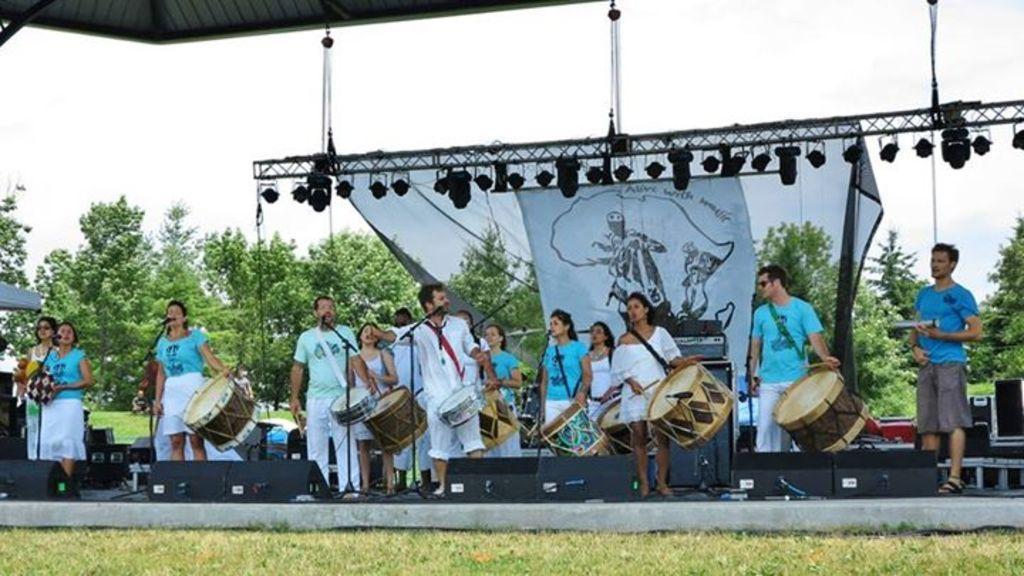Could you give a brief overview of what you see in this image? This picture is clicked outside. In the foreground we can see the green grass. In the center we can see the group of people standing on the ground and seems to be playing musical instruments and there are some microphones attached to the stands. At the top we can see the tent, focusing lights attached to the metal rods. In the background we can see a white color curtain and we can see the sky and the trees. 